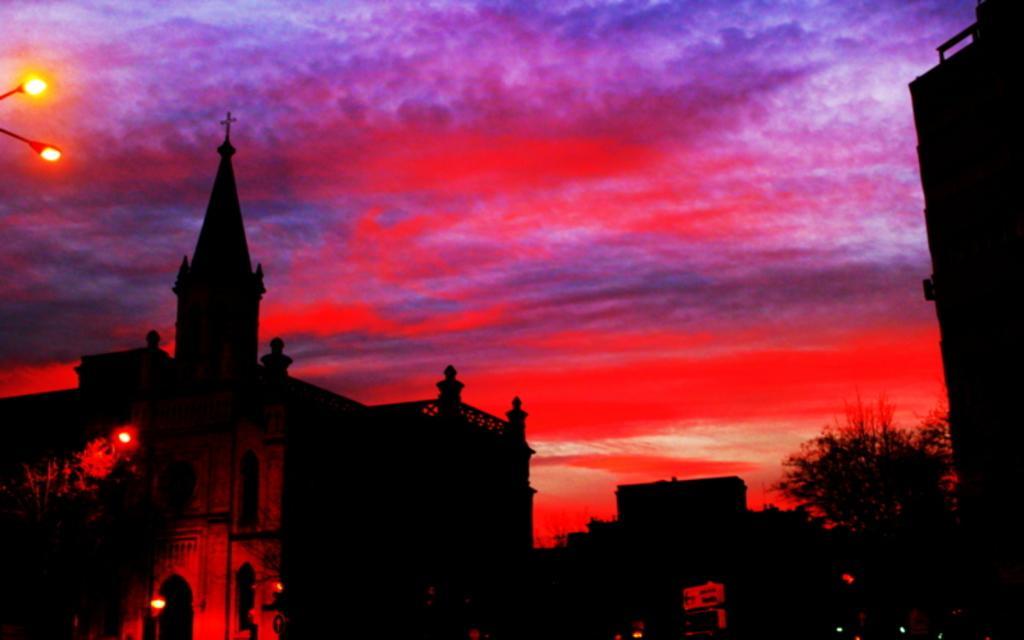Describe this image in one or two sentences. In this picture we can see few buildings, trees and lights, in the background we can see red color sky. 